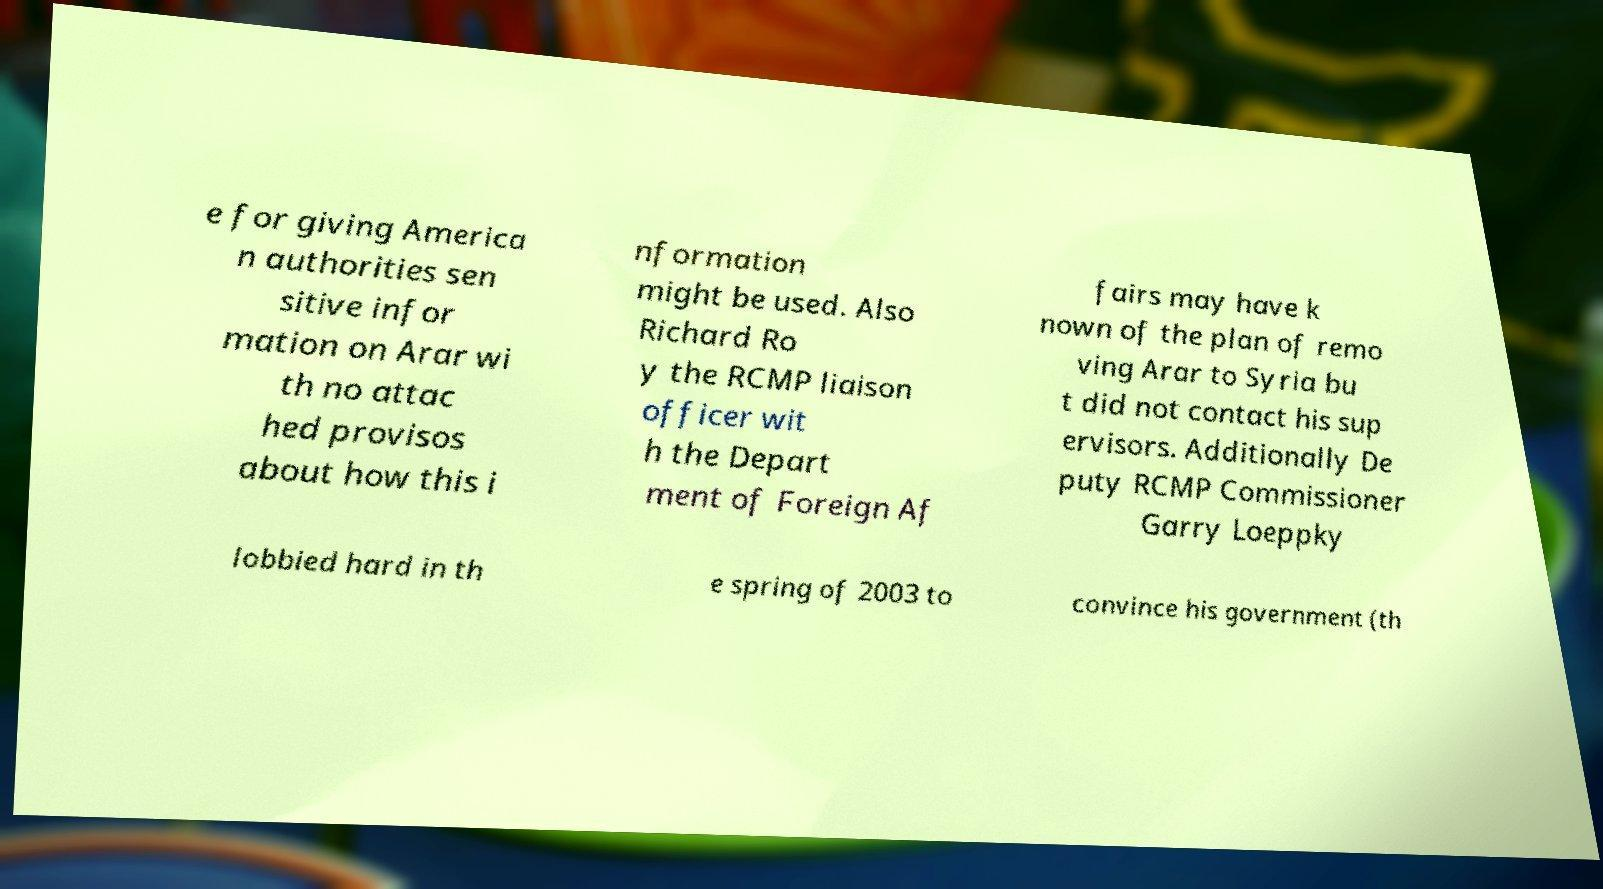Please identify and transcribe the text found in this image. e for giving America n authorities sen sitive infor mation on Arar wi th no attac hed provisos about how this i nformation might be used. Also Richard Ro y the RCMP liaison officer wit h the Depart ment of Foreign Af fairs may have k nown of the plan of remo ving Arar to Syria bu t did not contact his sup ervisors. Additionally De puty RCMP Commissioner Garry Loeppky lobbied hard in th e spring of 2003 to convince his government (th 